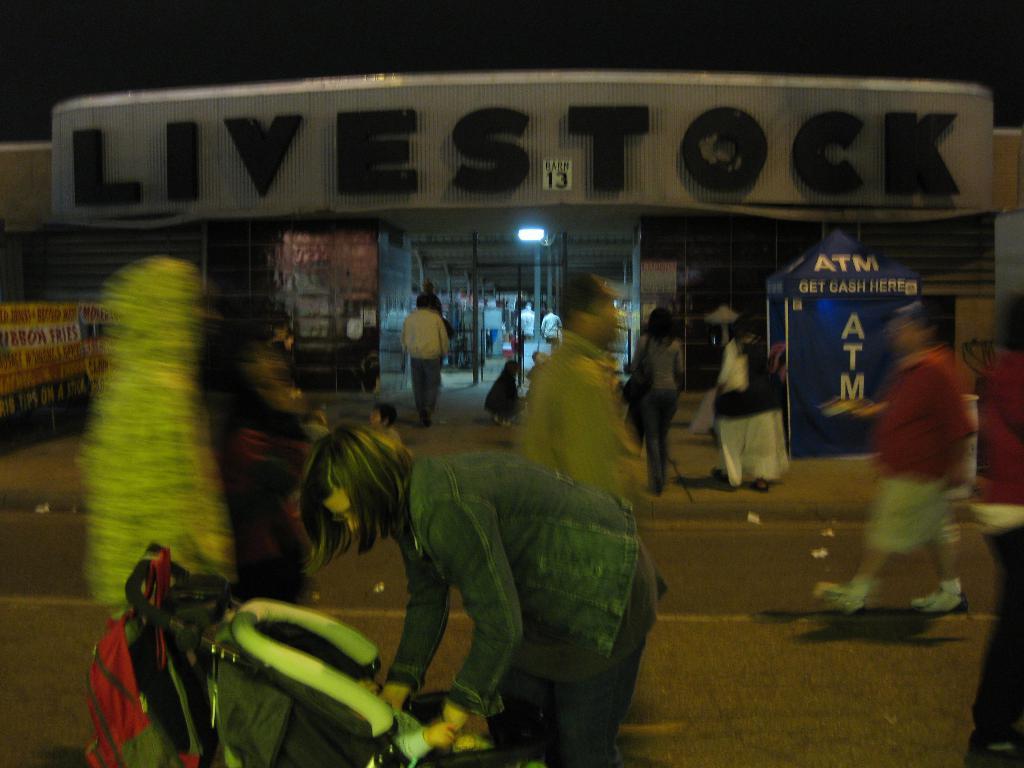Could you give a brief overview of what you see in this image? This image is taken outdoors. At the bottom of the image there is a road. In the background there is a store with walls and doors. There are many boards with text on them. There is a text on the wall. A few people are walking on the road and a few are standing. There is a stall. In the middle of the image a woman is standing and there is a baby carrier with a baby in it. 